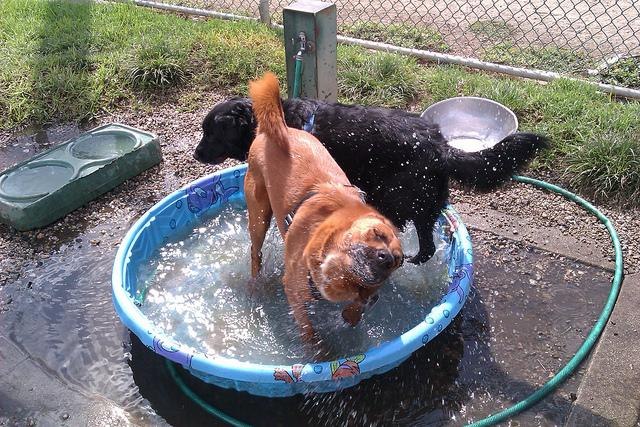What color is the garden hose wrapped around the kiddie pool?

Choices:
A) turquoise
B) purple
C) red
D) green turquoise 